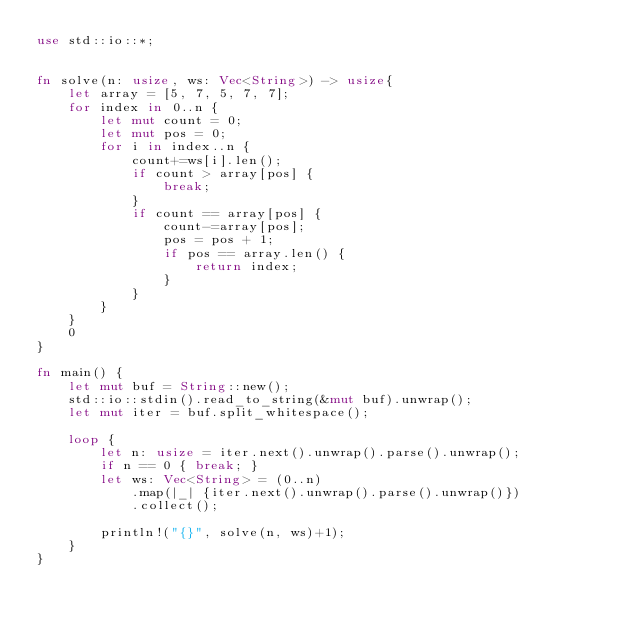<code> <loc_0><loc_0><loc_500><loc_500><_Rust_>use std::io::*;


fn solve(n: usize, ws: Vec<String>) -> usize{
    let array = [5, 7, 5, 7, 7];
    for index in 0..n {
        let mut count = 0;
        let mut pos = 0;
        for i in index..n {
            count+=ws[i].len();
            if count > array[pos] {
                break;
            }
            if count == array[pos] {
                count-=array[pos];
                pos = pos + 1;
                if pos == array.len() {
                    return index;
                }
            }
        }
    }
    0
}

fn main() {
    let mut buf = String::new();
    std::io::stdin().read_to_string(&mut buf).unwrap();
    let mut iter = buf.split_whitespace();

    loop {
        let n: usize = iter.next().unwrap().parse().unwrap();
        if n == 0 { break; }
        let ws: Vec<String> = (0..n)
            .map(|_| {iter.next().unwrap().parse().unwrap()})
            .collect();

        println!("{}", solve(n, ws)+1);
    }
}

</code> 